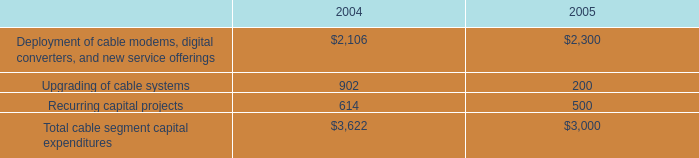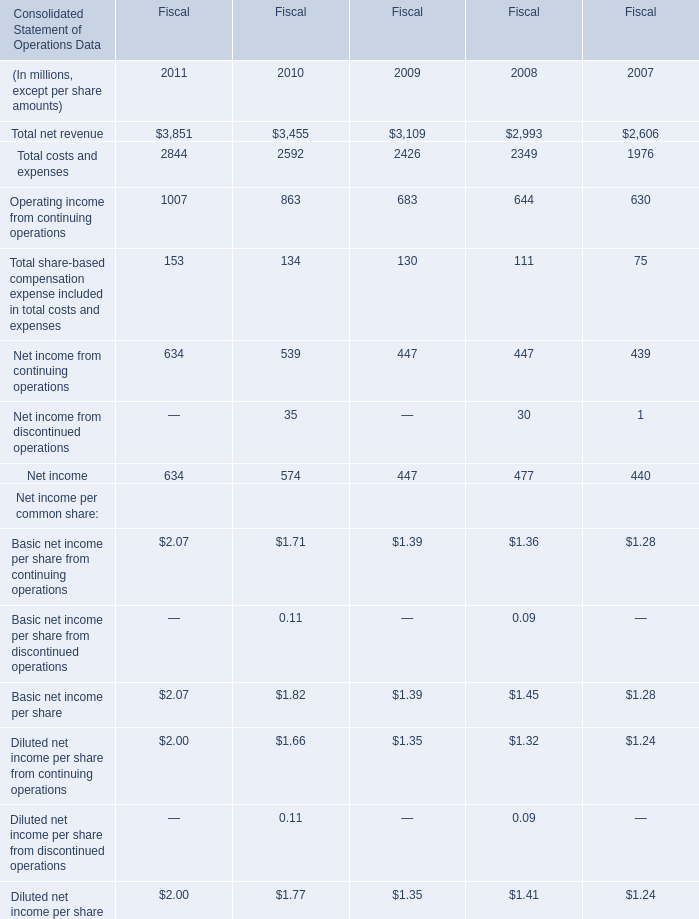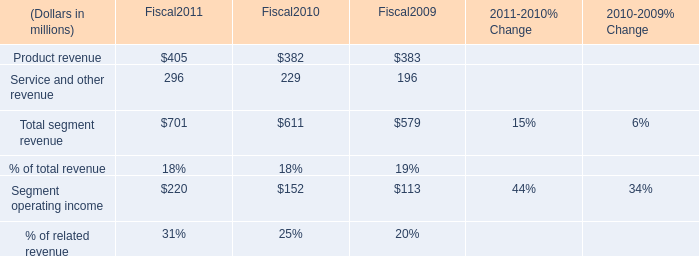What will Net income reach in Fiscal 2011 if it continues to grow at the same growth rate as in Fiscal 2010? (in million) 
Computations: (574 * (1 + ((574 - 447) / 447)))
Answer: 737.08277. 